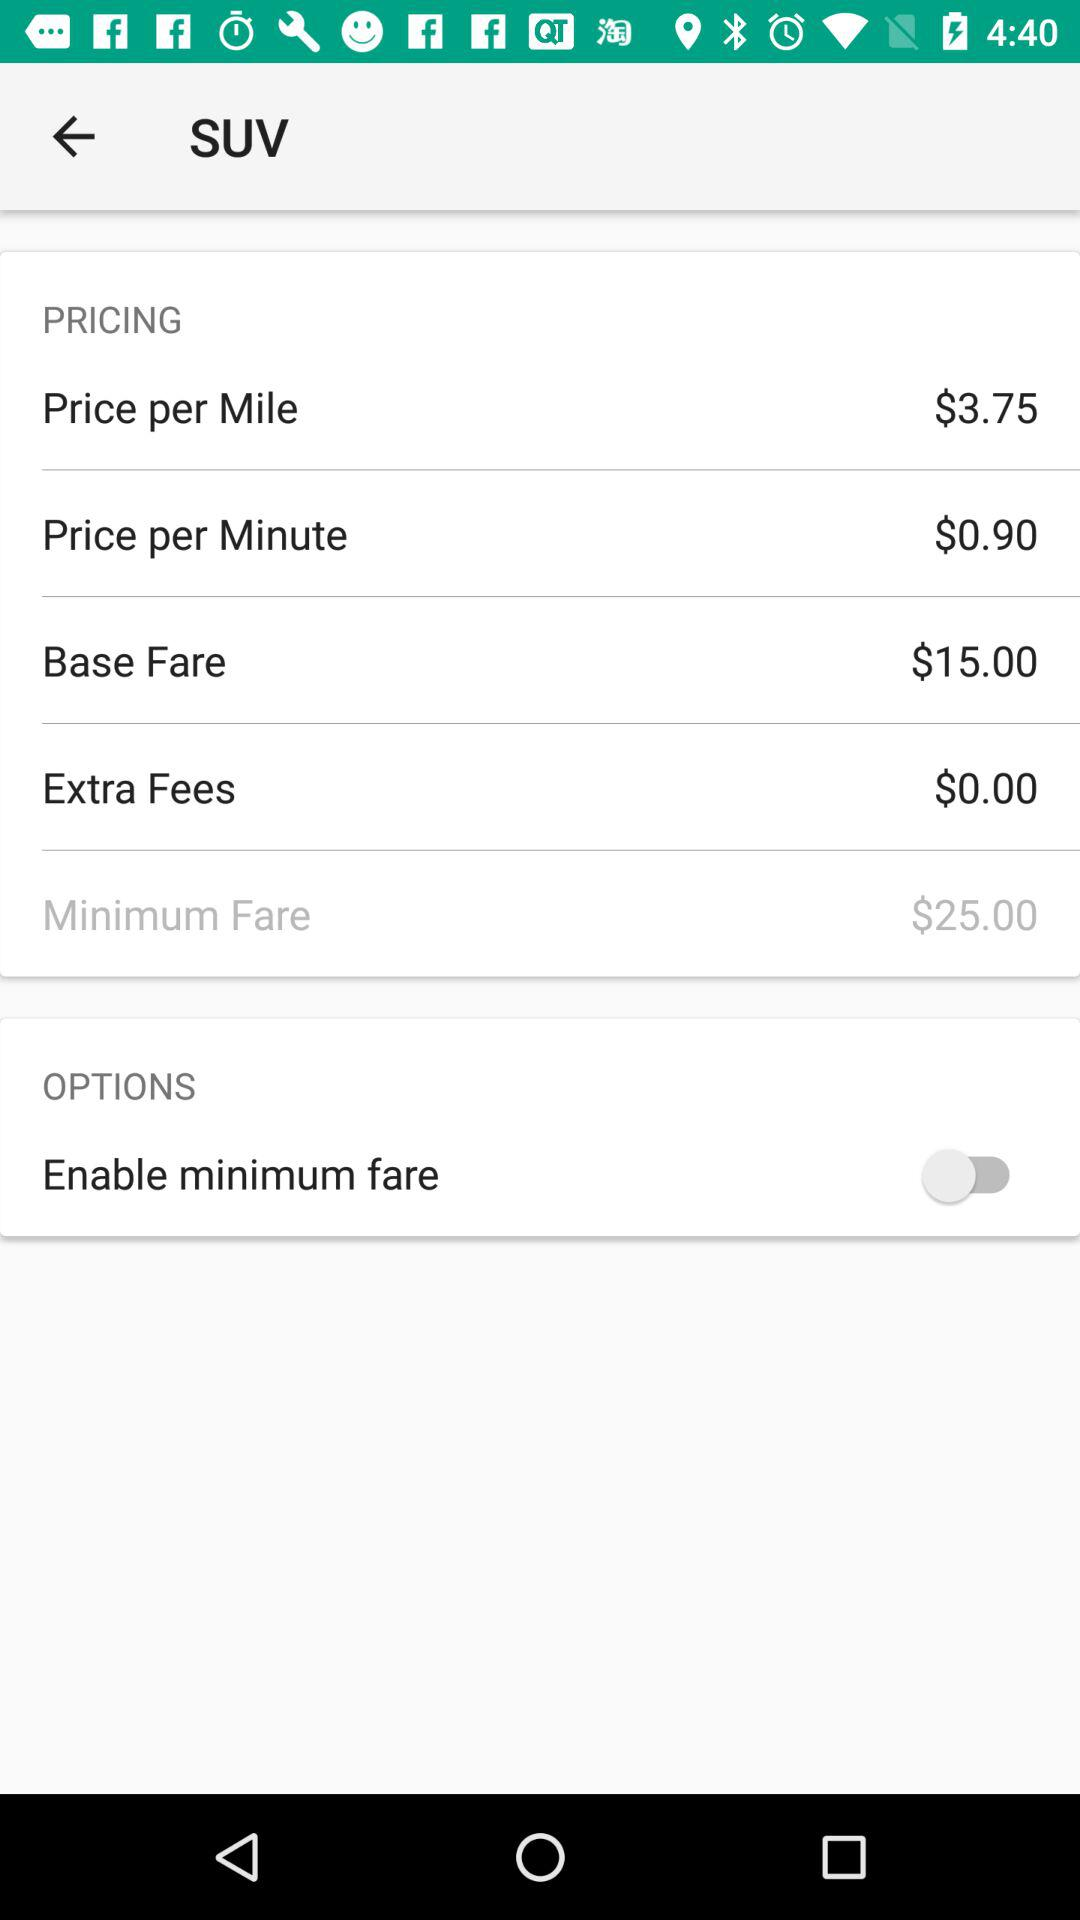What's the status of "Enable minimum fare"? The status is "off". 